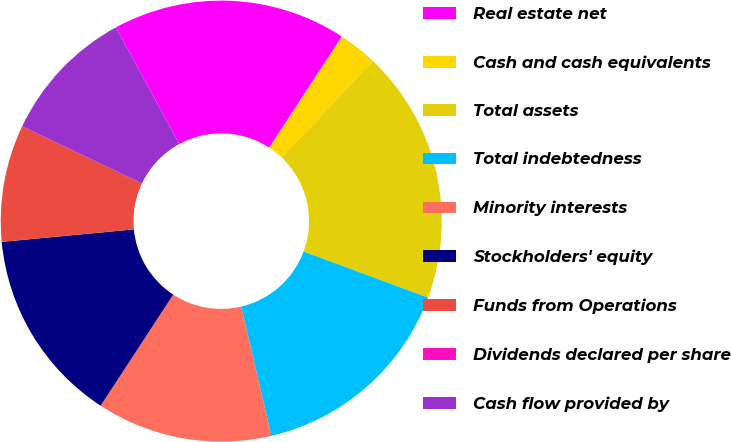Convert chart to OTSL. <chart><loc_0><loc_0><loc_500><loc_500><pie_chart><fcel>Real estate net<fcel>Cash and cash equivalents<fcel>Total assets<fcel>Total indebtedness<fcel>Minority interests<fcel>Stockholders' equity<fcel>Funds from Operations<fcel>Dividends declared per share<fcel>Cash flow provided by<nl><fcel>17.14%<fcel>2.86%<fcel>18.57%<fcel>15.71%<fcel>12.86%<fcel>14.29%<fcel>8.57%<fcel>0.0%<fcel>10.0%<nl></chart> 